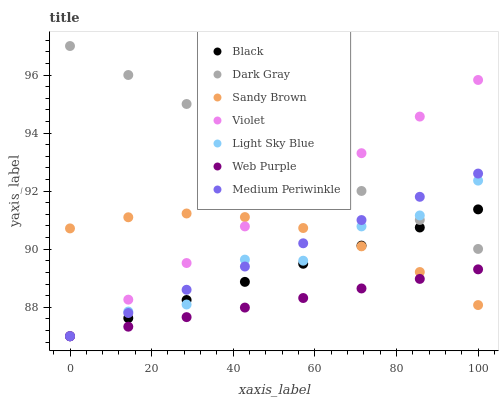Does Web Purple have the minimum area under the curve?
Answer yes or no. Yes. Does Dark Gray have the maximum area under the curve?
Answer yes or no. Yes. Does Dark Gray have the minimum area under the curve?
Answer yes or no. No. Does Web Purple have the maximum area under the curve?
Answer yes or no. No. Is Medium Periwinkle the smoothest?
Answer yes or no. Yes. Is Light Sky Blue the roughest?
Answer yes or no. Yes. Is Dark Gray the smoothest?
Answer yes or no. No. Is Dark Gray the roughest?
Answer yes or no. No. Does Medium Periwinkle have the lowest value?
Answer yes or no. Yes. Does Dark Gray have the lowest value?
Answer yes or no. No. Does Dark Gray have the highest value?
Answer yes or no. Yes. Does Web Purple have the highest value?
Answer yes or no. No. Is Web Purple less than Dark Gray?
Answer yes or no. Yes. Is Dark Gray greater than Sandy Brown?
Answer yes or no. Yes. Does Violet intersect Sandy Brown?
Answer yes or no. Yes. Is Violet less than Sandy Brown?
Answer yes or no. No. Is Violet greater than Sandy Brown?
Answer yes or no. No. Does Web Purple intersect Dark Gray?
Answer yes or no. No. 